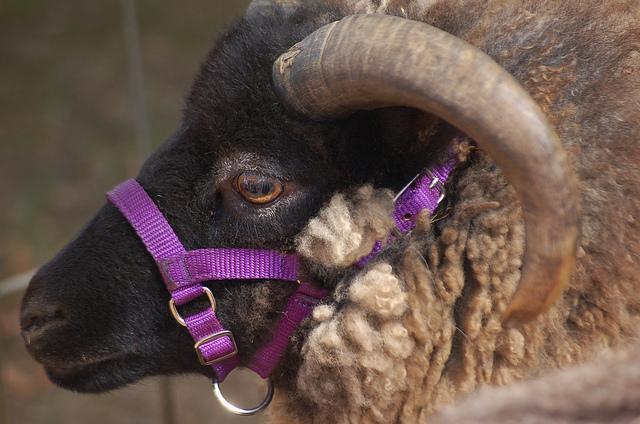How many girls are in this picture?
Give a very brief answer. 0. 